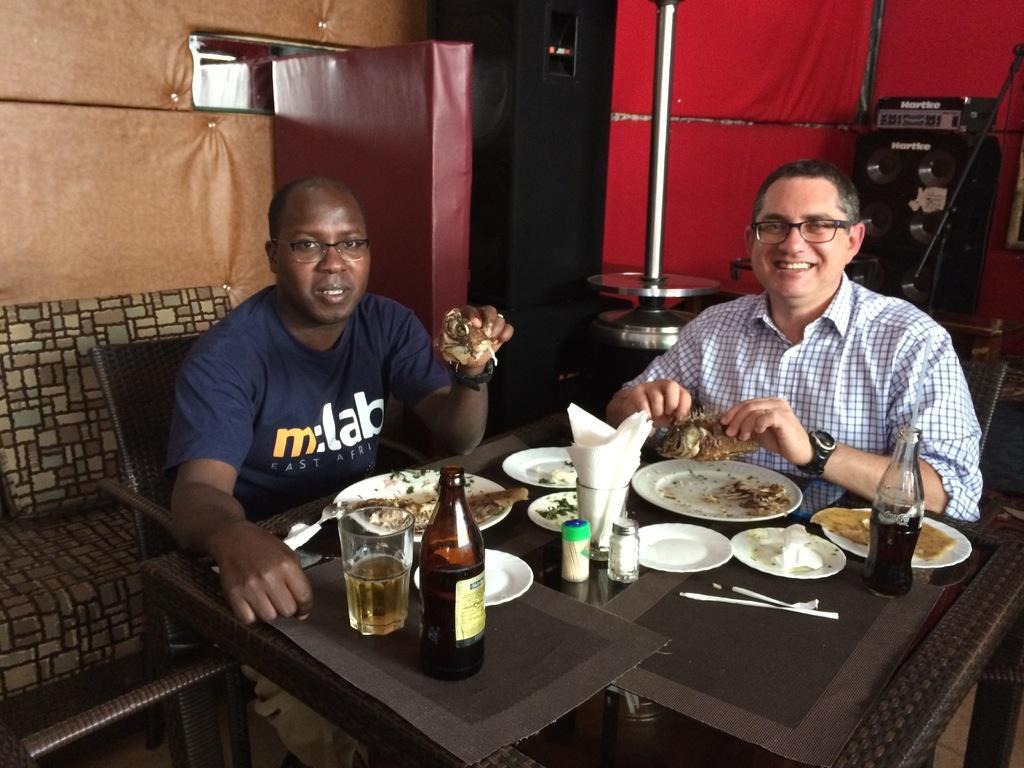Can you describe this image briefly? In this image there are two men who are sitting around the table. On the table there are plates,glasses,bottles and tissue papers. In the plate there is some food. In the background there is an iron pole. On the left side top there is a wall. Behind the chair there is a sofa. 